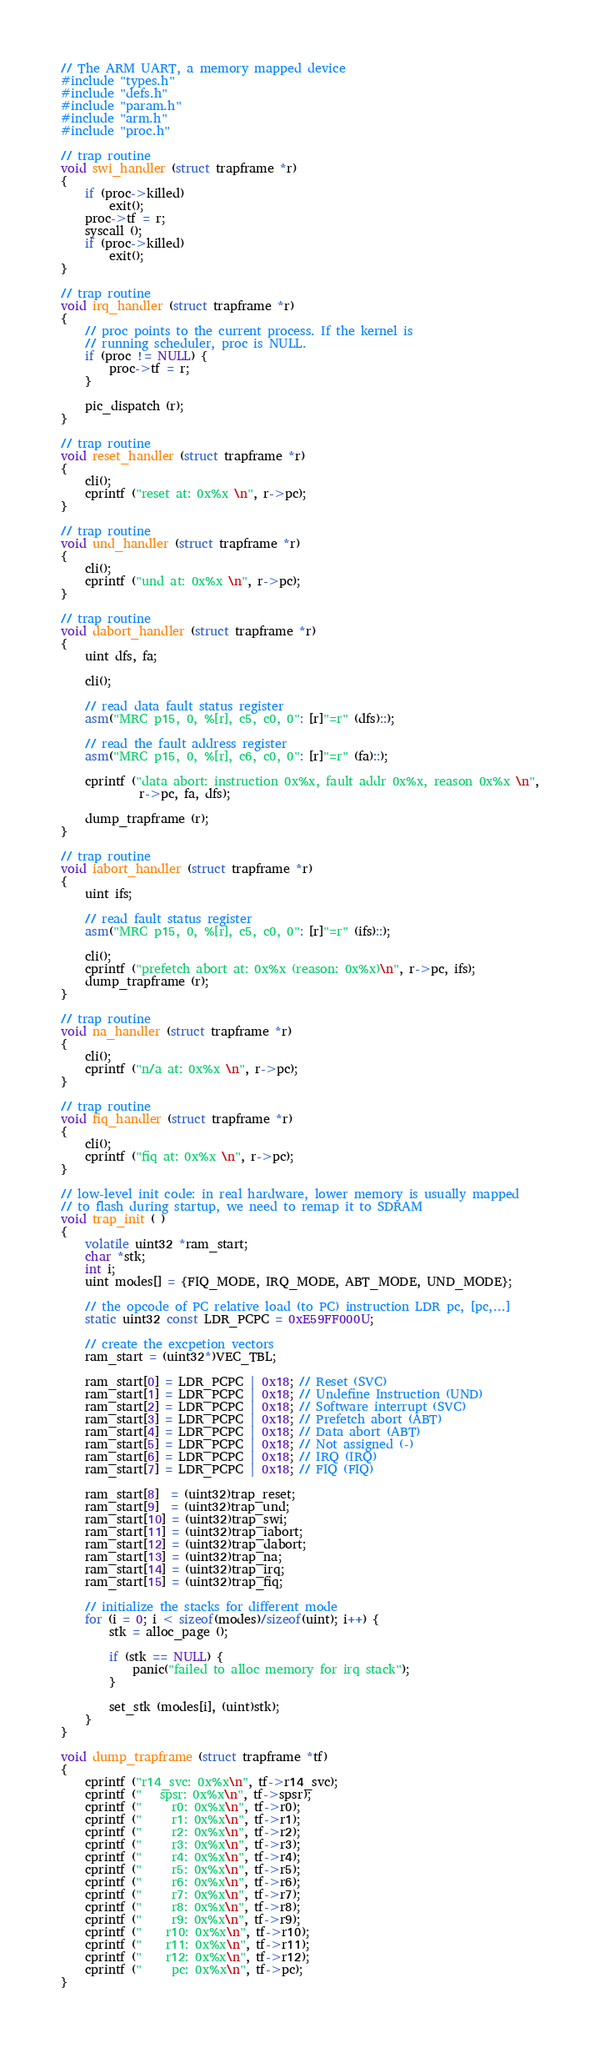<code> <loc_0><loc_0><loc_500><loc_500><_C_>// The ARM UART, a memory mapped device
#include "types.h"
#include "defs.h"
#include "param.h"
#include "arm.h"
#include "proc.h"

// trap routine
void swi_handler (struct trapframe *r)
{
    if (proc->killed)
        exit();
    proc->tf = r;
    syscall ();
    if (proc->killed)
        exit();
}

// trap routine
void irq_handler (struct trapframe *r)
{
    // proc points to the current process. If the kernel is
    // running scheduler, proc is NULL.
    if (proc != NULL) {
        proc->tf = r;
    }

    pic_dispatch (r);
}

// trap routine
void reset_handler (struct trapframe *r)
{
    cli();
    cprintf ("reset at: 0x%x \n", r->pc);
}

// trap routine
void und_handler (struct trapframe *r)
{
    cli();
    cprintf ("und at: 0x%x \n", r->pc);
}

// trap routine
void dabort_handler (struct trapframe *r)
{
    uint dfs, fa;

    cli();

    // read data fault status register
    asm("MRC p15, 0, %[r], c5, c0, 0": [r]"=r" (dfs)::);

    // read the fault address register
    asm("MRC p15, 0, %[r], c6, c0, 0": [r]"=r" (fa)::);
    
    cprintf ("data abort: instruction 0x%x, fault addr 0x%x, reason 0x%x \n",
             r->pc, fa, dfs);
    
    dump_trapframe (r);
}

// trap routine
void iabort_handler (struct trapframe *r)
{
    uint ifs;
    
    // read fault status register
    asm("MRC p15, 0, %[r], c5, c0, 0": [r]"=r" (ifs)::);

    cli();
    cprintf ("prefetch abort at: 0x%x (reason: 0x%x)\n", r->pc, ifs);
    dump_trapframe (r);
}

// trap routine
void na_handler (struct trapframe *r)
{
    cli();
    cprintf ("n/a at: 0x%x \n", r->pc);
}

// trap routine
void fiq_handler (struct trapframe *r)
{
    cli();
    cprintf ("fiq at: 0x%x \n", r->pc);
}

// low-level init code: in real hardware, lower memory is usually mapped
// to flash during startup, we need to remap it to SDRAM
void trap_init ( )
{
    volatile uint32 *ram_start;
    char *stk;
    int i;
    uint modes[] = {FIQ_MODE, IRQ_MODE, ABT_MODE, UND_MODE};

    // the opcode of PC relative load (to PC) instruction LDR pc, [pc,...]
    static uint32 const LDR_PCPC = 0xE59FF000U;

    // create the excpetion vectors
    ram_start = (uint32*)VEC_TBL;

    ram_start[0] = LDR_PCPC | 0x18; // Reset (SVC)
    ram_start[1] = LDR_PCPC | 0x18; // Undefine Instruction (UND)
    ram_start[2] = LDR_PCPC | 0x18; // Software interrupt (SVC)
    ram_start[3] = LDR_PCPC | 0x18; // Prefetch abort (ABT)
    ram_start[4] = LDR_PCPC | 0x18; // Data abort (ABT)
    ram_start[5] = LDR_PCPC | 0x18; // Not assigned (-)
    ram_start[6] = LDR_PCPC | 0x18; // IRQ (IRQ)
    ram_start[7] = LDR_PCPC | 0x18; // FIQ (FIQ)

    ram_start[8]  = (uint32)trap_reset;
    ram_start[9]  = (uint32)trap_und;
    ram_start[10] = (uint32)trap_swi;
    ram_start[11] = (uint32)trap_iabort;
    ram_start[12] = (uint32)trap_dabort;
    ram_start[13] = (uint32)trap_na;
    ram_start[14] = (uint32)trap_irq;
    ram_start[15] = (uint32)trap_fiq;

    // initialize the stacks for different mode
    for (i = 0; i < sizeof(modes)/sizeof(uint); i++) {
        stk = alloc_page ();

        if (stk == NULL) {
            panic("failed to alloc memory for irq stack");
        }

        set_stk (modes[i], (uint)stk);
    }
}

void dump_trapframe (struct trapframe *tf)
{
    cprintf ("r14_svc: 0x%x\n", tf->r14_svc);
    cprintf ("   spsr: 0x%x\n", tf->spsr);
    cprintf ("     r0: 0x%x\n", tf->r0);
    cprintf ("     r1: 0x%x\n", tf->r1);
    cprintf ("     r2: 0x%x\n", tf->r2);
    cprintf ("     r3: 0x%x\n", tf->r3);
    cprintf ("     r4: 0x%x\n", tf->r4);
    cprintf ("     r5: 0x%x\n", tf->r5);
    cprintf ("     r6: 0x%x\n", tf->r6);
    cprintf ("     r7: 0x%x\n", tf->r7);
    cprintf ("     r8: 0x%x\n", tf->r8);
    cprintf ("     r9: 0x%x\n", tf->r9);
    cprintf ("    r10: 0x%x\n", tf->r10);
    cprintf ("    r11: 0x%x\n", tf->r11);
    cprintf ("    r12: 0x%x\n", tf->r12);
    cprintf ("     pc: 0x%x\n", tf->pc);
}
</code> 